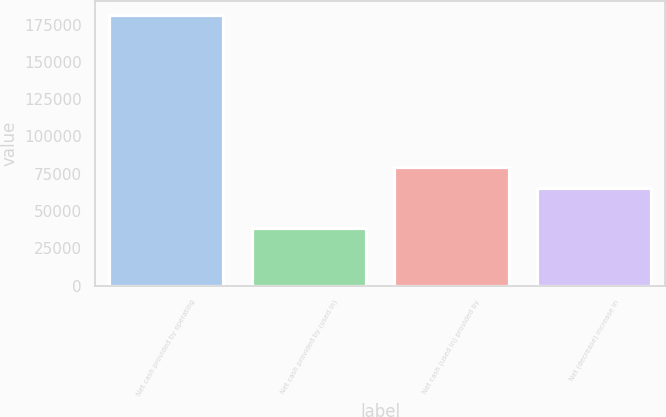Convert chart to OTSL. <chart><loc_0><loc_0><loc_500><loc_500><bar_chart><fcel>Net cash provided by operating<fcel>Net cash provided by (used in)<fcel>Net cash (used in) provided by<fcel>Net (decrease) increase in<nl><fcel>181522<fcel>38318<fcel>79771.4<fcel>65451<nl></chart> 